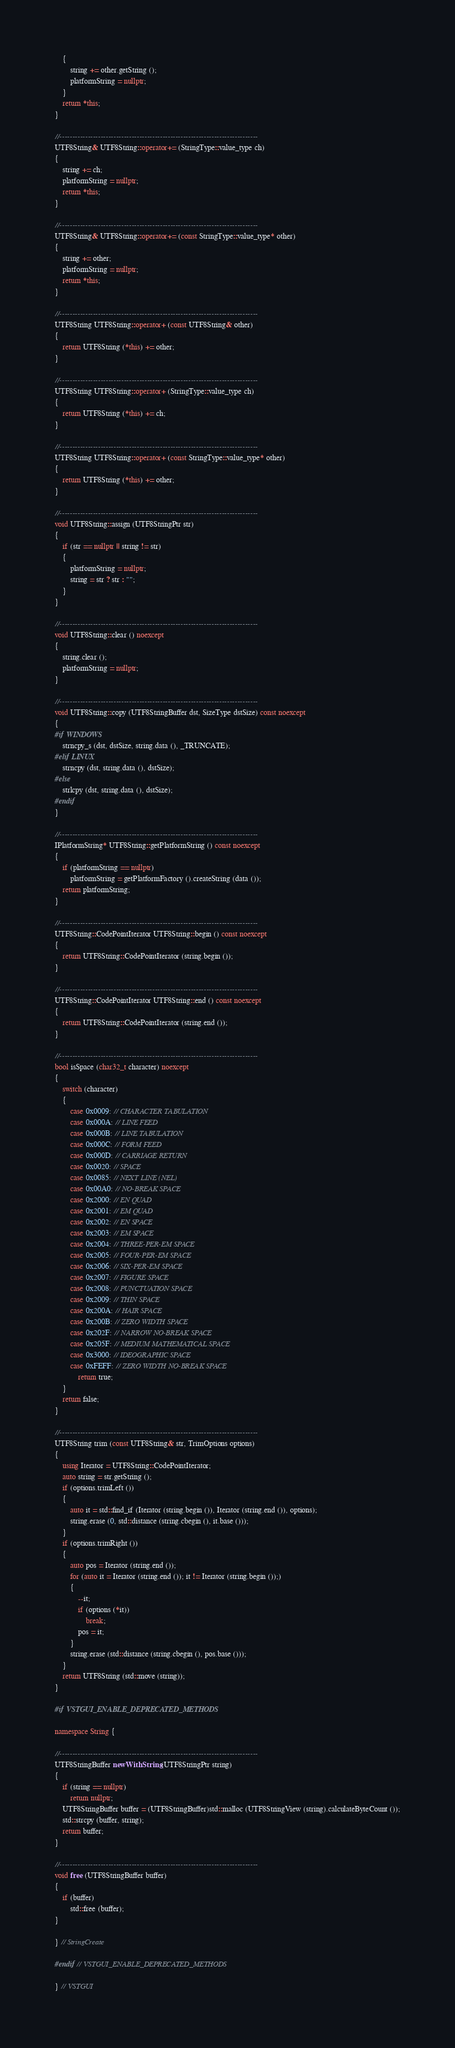Convert code to text. <code><loc_0><loc_0><loc_500><loc_500><_C++_>	{
		string += other.getString ();
		platformString = nullptr;
	}
	return *this;
}

//-----------------------------------------------------------------------------
UTF8String& UTF8String::operator+= (StringType::value_type ch)
{
	string += ch;
	platformString = nullptr;
	return *this;
}

//-----------------------------------------------------------------------------
UTF8String& UTF8String::operator+= (const StringType::value_type* other)
{
	string += other;
	platformString = nullptr;
	return *this;
}

//-----------------------------------------------------------------------------
UTF8String UTF8String::operator+ (const UTF8String& other)
{
	return UTF8String (*this) += other;
}

//-----------------------------------------------------------------------------
UTF8String UTF8String::operator+ (StringType::value_type ch)
{
	return UTF8String (*this) += ch;
}

//-----------------------------------------------------------------------------
UTF8String UTF8String::operator+ (const StringType::value_type* other)
{
	return UTF8String (*this) += other;
}

//-----------------------------------------------------------------------------
void UTF8String::assign (UTF8StringPtr str)
{
	if (str == nullptr || string != str)
	{
		platformString = nullptr;
		string = str ? str : "";
	}
}

//-----------------------------------------------------------------------------
void UTF8String::clear () noexcept
{
	string.clear ();
	platformString = nullptr;
}

//-----------------------------------------------------------------------------
void UTF8String::copy (UTF8StringBuffer dst, SizeType dstSize) const noexcept
{
#if WINDOWS
	strncpy_s (dst, dstSize, string.data (), _TRUNCATE);
#elif LINUX
	strncpy (dst, string.data (), dstSize);
#else
	strlcpy (dst, string.data (), dstSize);
#endif
}

//-----------------------------------------------------------------------------
IPlatformString* UTF8String::getPlatformString () const noexcept
{
	if (platformString == nullptr)
		platformString = getPlatformFactory ().createString (data ());
	return platformString;
}

//-----------------------------------------------------------------------------
UTF8String::CodePointIterator UTF8String::begin () const noexcept
{
	return UTF8String::CodePointIterator (string.begin ());
}

//-----------------------------------------------------------------------------
UTF8String::CodePointIterator UTF8String::end () const noexcept
{
	return UTF8String::CodePointIterator (string.end ());
}

//-----------------------------------------------------------------------------
bool isSpace (char32_t character) noexcept
{
	switch (character)
	{
		case 0x0009: // CHARACTER TABULATION
		case 0x000A: // LINE FEED
		case 0x000B: // LINE TABULATION
		case 0x000C: // FORM FEED
		case 0x000D: // CARRIAGE RETURN
		case 0x0020: // SPACE
		case 0x0085: // NEXT LINE (NEL)
		case 0x00A0: // NO-BREAK SPACE
		case 0x2000: // EN QUAD
		case 0x2001: // EM QUAD
		case 0x2002: // EN SPACE
		case 0x2003: // EM SPACE
		case 0x2004: // THREE-PER-EM SPACE
		case 0x2005: // FOUR-PER-EM SPACE
		case 0x2006: // SIX-PER-EM SPACE
		case 0x2007: // FIGURE SPACE
		case 0x2008: // PUNCTUATION SPACE
		case 0x2009: // THIN SPACE
		case 0x200A: // HAIR SPACE
		case 0x200B: // ZERO WIDTH SPACE
		case 0x202F: // NARROW NO-BREAK SPACE
		case 0x205F: // MEDIUM MATHEMATICAL SPACE
		case 0x3000: // IDEOGRAPHIC SPACE
		case 0xFEFF: // ZERO WIDTH NO-BREAK SPACE
			return true;
	}
	return false;
}

//-----------------------------------------------------------------------------
UTF8String trim (const UTF8String& str, TrimOptions options)
{
	using Iterator = UTF8String::CodePointIterator;
	auto string = str.getString ();
	if (options.trimLeft ())
	{
		auto it = std::find_if (Iterator (string.begin ()), Iterator (string.end ()), options);
		string.erase (0, std::distance (string.cbegin (), it.base ()));
	}
	if (options.trimRight ())
	{
		auto pos = Iterator (string.end ());
		for (auto it = Iterator (string.end ()); it != Iterator (string.begin ());)
		{
			--it;
			if (options (*it))
				break;
			pos = it;
		}
		string.erase (std::distance (string.cbegin (), pos.base ()));
	}
	return UTF8String (std::move (string));
}

#if VSTGUI_ENABLE_DEPRECATED_METHODS

namespace String {

//-----------------------------------------------------------------------------
UTF8StringBuffer newWithString (UTF8StringPtr string)
{
	if (string == nullptr)
		return nullptr;
	UTF8StringBuffer buffer = (UTF8StringBuffer)std::malloc (UTF8StringView (string).calculateByteCount ());
	std::strcpy (buffer, string);
	return buffer;
}

//-----------------------------------------------------------------------------
void free (UTF8StringBuffer buffer)
{
	if (buffer)
		std::free (buffer);
}

} // StringCreate

#endif // VSTGUI_ENABLE_DEPRECATED_METHODS

} // VSTGUI
</code> 